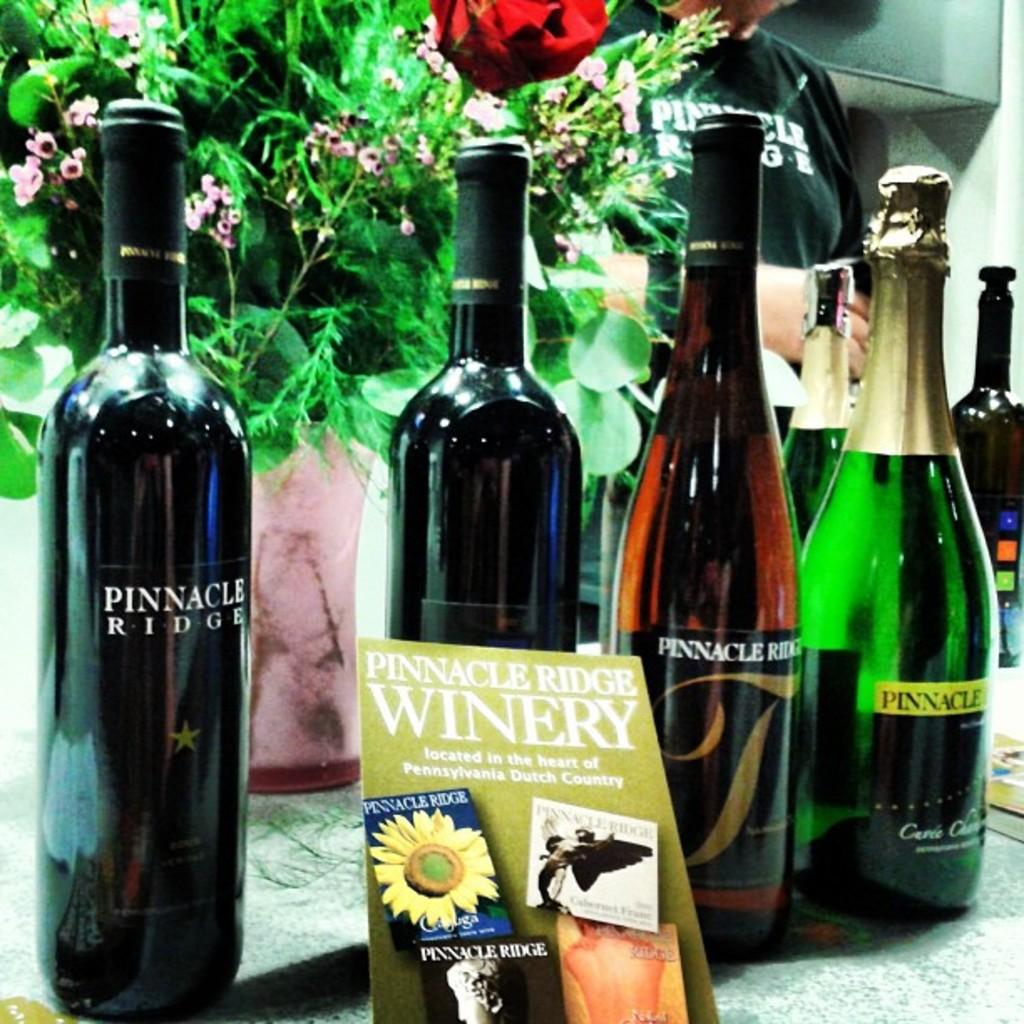<image>
Render a clear and concise summary of the photo. Bottles of Pinnacle Ridge wine sitting on a table next to a vase of flowers. 